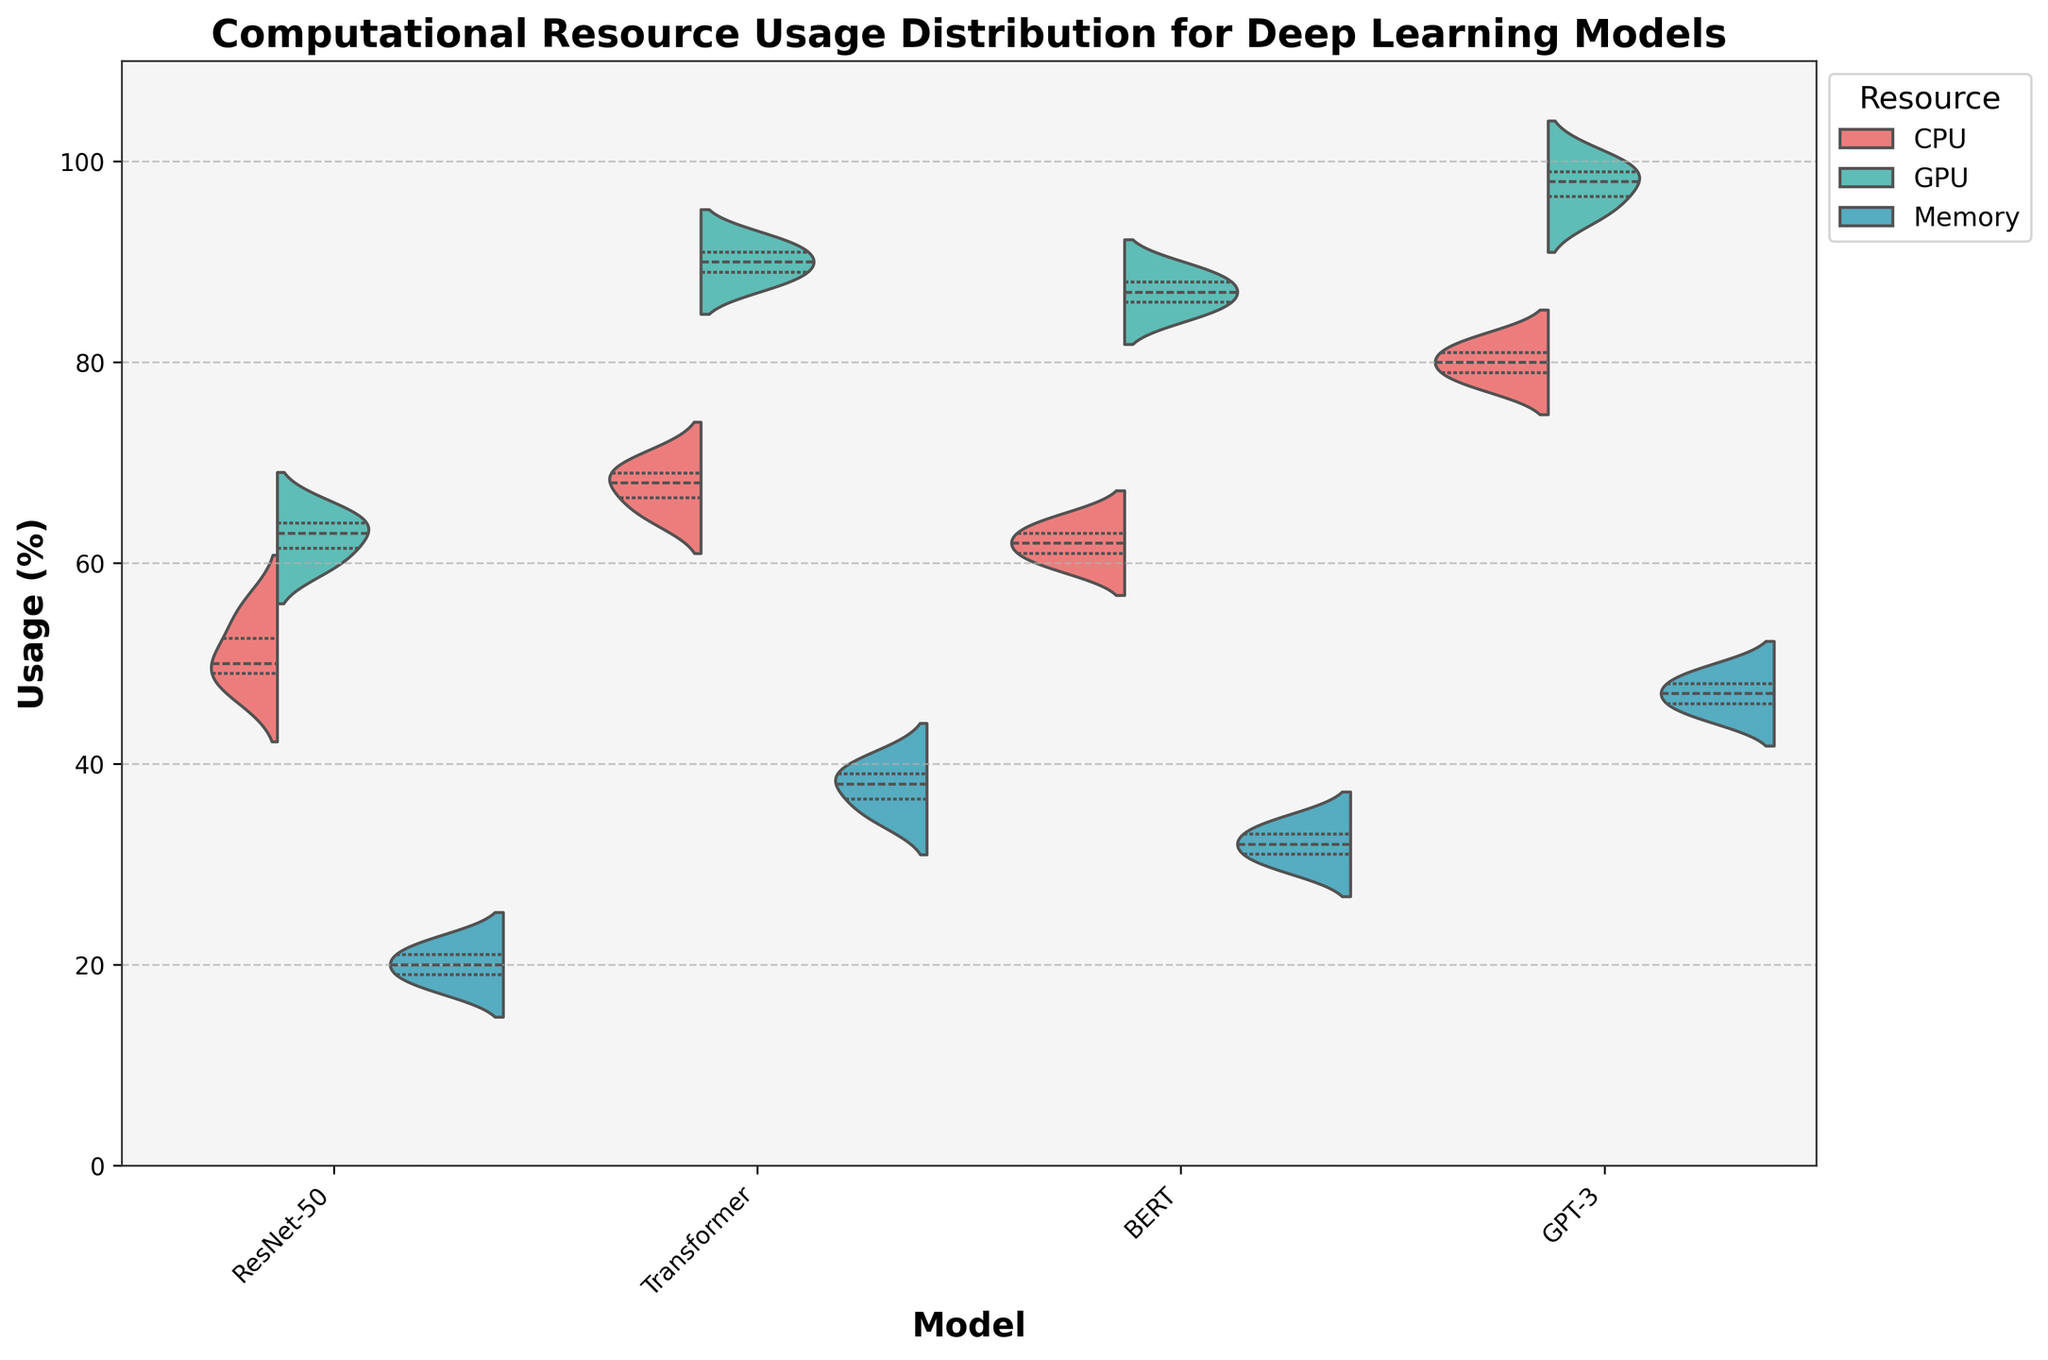What is the title of the violin chart? The title of the chart is printed at the top and reads "Computational Resource Usage Distribution for Deep Learning Models"
Answer: Computational Resource Usage Distribution for Deep Learning Models What is the range of the y-axis in the chart? The y-axis range is indicated by the numbers along the y-axis on the left side of the plot, spanning from 0 to 110.
Answer: 0 to 110 Which model uses the most GPU resource on average? The GPU usage for each model can be observed in the chart section labeled 'GPU' for each model. The chart shows that GPT-3 uses the most GPU resource on average compared to the other models.
Answer: GPT-3 What are the quartile boundaries for CPU usage of the ResNet-50 model? The violin plot shows quartile boundaries as inner lines within each violin. For the ResNet-50 CPU usage section, these boundaries can be visually observed as approximately 48, 50, 53, and 55.
Answer: 48, 50, 53, 55 Which model uses the most memory on average? By examining the 'Memory' section of each model's violin plot, the Transformer model shows the highest memory usage on average, consistent with other models.
Answer: Transformer Compare the CPU usage of the ResNet-50 model and the Transformer model. Which has a wider distribution? Observing the span of the violins for CPU usage, the Transformer model has a wider span than the ResNet-50, indicating a wider distribution.
Answer: Transformer Is the median GPU usage for the BERT model higher or lower than the median GPU usage for the ResNet-50 model? The median GPU usage line within the violins for each model shows that BERT has a higher median than ResNet-50.
Answer: Higher Which computational resource shows the smallest distribution range across all models? Each resource's distribution range can be seen by the spread of the violins. The Memory usage violins for all models are relatively narrower compared to CPU and GPU.
Answer: Memory What does the light background color of the plot indicate? The light background color does not convey any specific data but is used to keep the plot visually clear and distinct.
Answer: Visual clarity Which model has the highest median CPU usage? The median CPU usage line within the violins shows that GPT-3 has the highest median CPU usage compared to other models.
Answer: GPT-3 